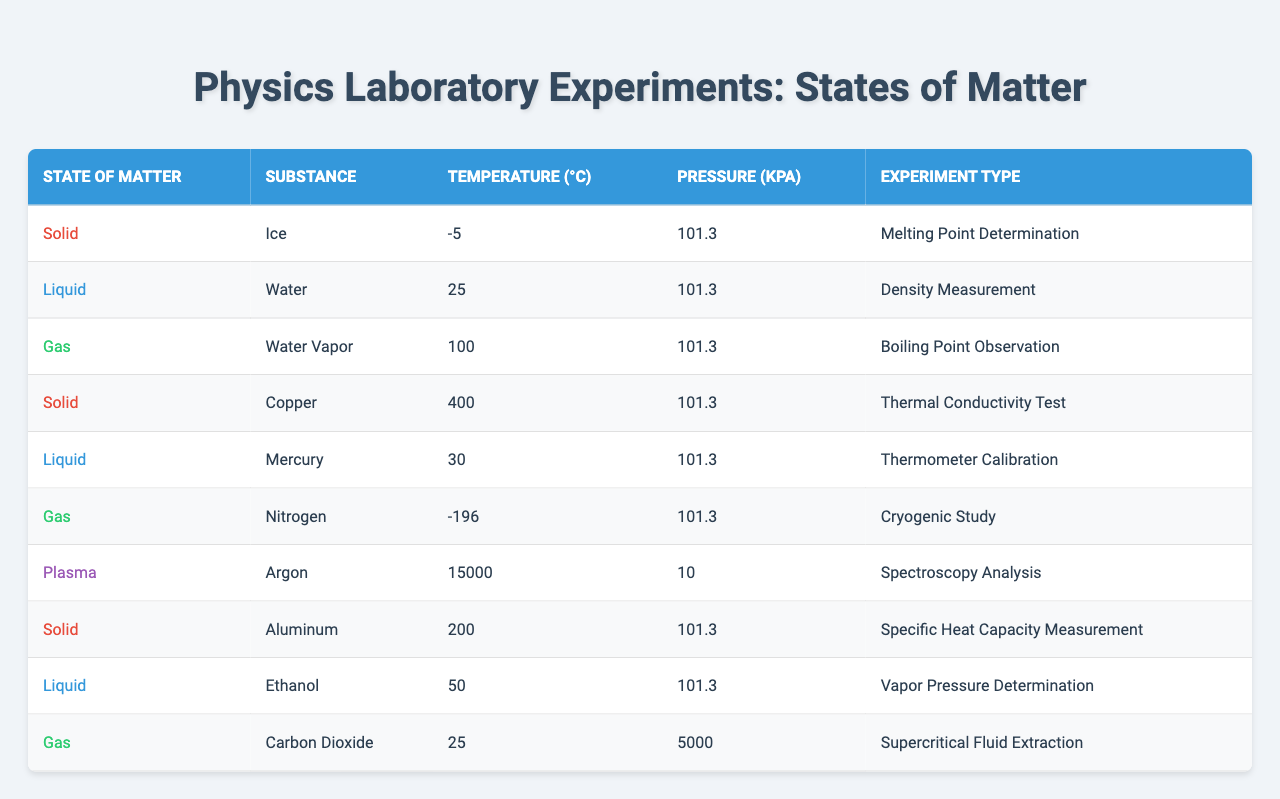What is the temperature reading for ice? From the table, the temperature for ice, a solid, is indicated as -5°C.
Answer: -5°C What is the pressure reading for water vapor? The table shows that the pressure for water vapor is 101.3 kPa.
Answer: 101.3 kPa Which substance has the highest temperature in the table? Scanning the temperature values, argon in plasma state has the highest temperature reading of 15000°C.
Answer: Argon (15000°C) What is the state of matter for nitrogen? The table lists nitrogen as a gas, as shown in the column labeled "State of Matter."
Answer: Gas How many experiments were conducted for liquids? From the data, there are three liquid experiments involving water, mercury, and ethanol.
Answer: 3 Is the pressure for copper greater than 100 kPa? The table reveals that the pressure for copper is 101.3 kPa, which is equal to but not greater than 100 kPa.
Answer: No What is the average temperature of the solids listed in the table? The solid substances are ice (-5), copper (400), and aluminum (200). Adding these gives -5 + 400 + 200 = 595, and dividing by 3 results in an average of 595/3 ≈ 198.33°C.
Answer: 198.33°C For which substance is the experiment type "Thermometer Calibration"? According to the table, mercury is the substance used in the "Thermometer Calibration" experiment.
Answer: Mercury What is the pressure reading for supercritical carbon dioxide? The table specifies that carbon dioxide under supercritical conditions has a pressure of 5000 kPa.
Answer: 5000 kPa Which state of matter has the lowest temperature recorded in the table? The lowest temperature is -196°C, which corresponds to nitrogen, a gas.
Answer: Gas (Nitrogen) 